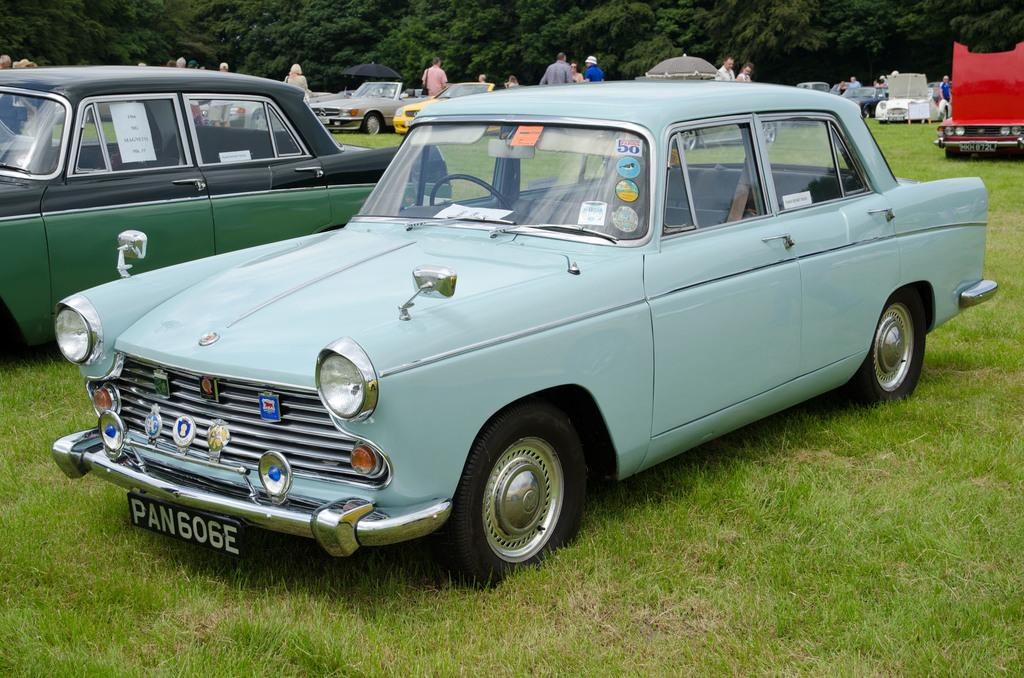What is the unusual location for the parked vehicles in the image? The vehicles are parked on the grass in the image. What can be seen in the background of the image? There are people, umbrellas, and trees in the background of the image. Who made the decision to park the vehicles on the grass in the image? The image does not provide information about who made the decision to park the vehicles on the grass. What type of beast can be seen roaming in the background of the image? There are no beasts visible in the image; it features vehicles parked on the grass, people, umbrellas, and trees in the background. 